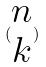<formula> <loc_0><loc_0><loc_500><loc_500>( \begin{matrix} n \\ k \end{matrix} )</formula> 